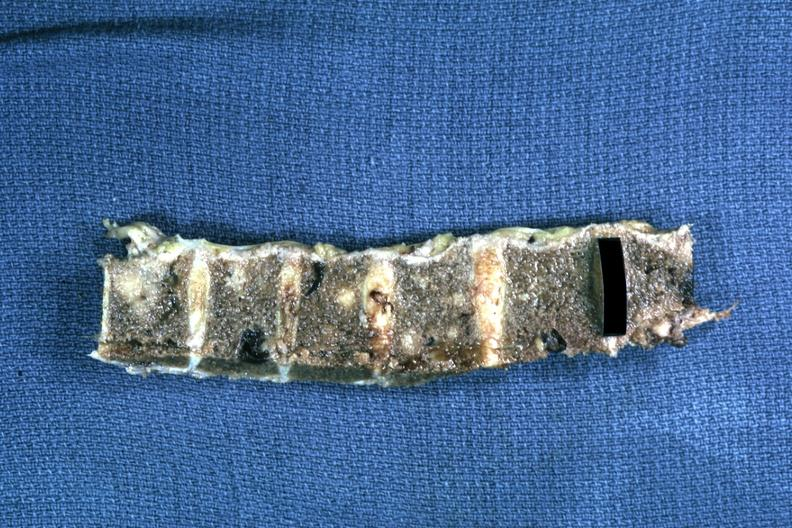what is present?
Answer the question using a single word or phrase. Joints 